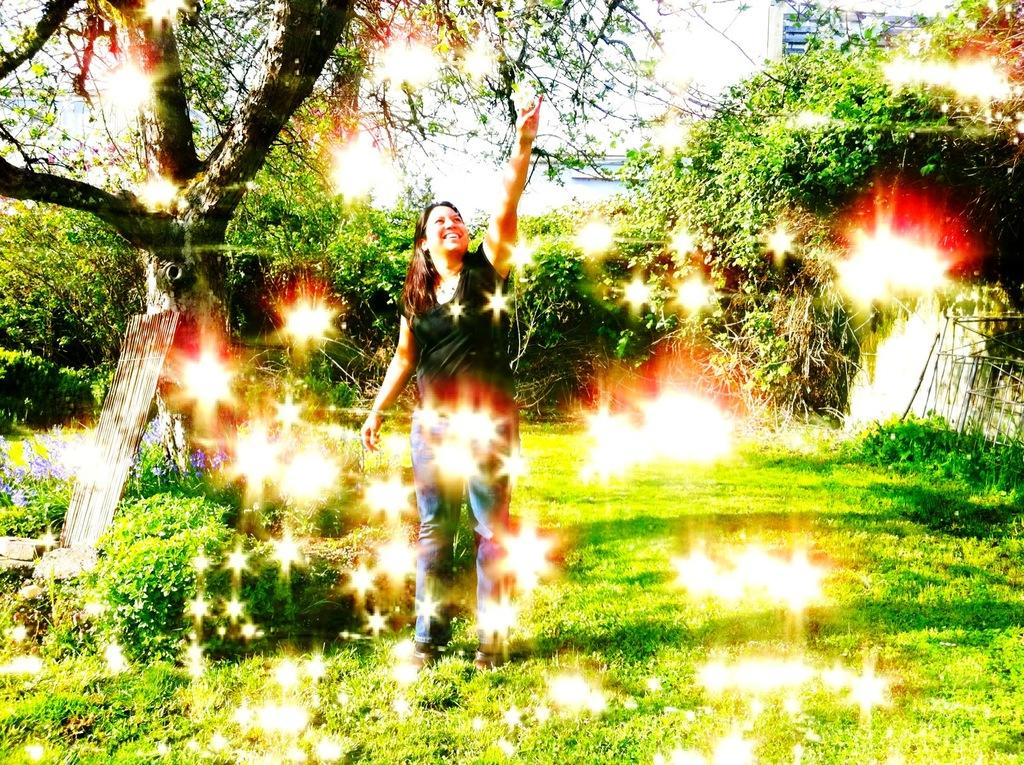What is the main subject of the image? The main subject of the image is a woman standing. What is the woman doing in the image? The woman is laughing in the image. What type of surface is the woman standing on? There is grass on the floor in the image. What can be seen in the background of the image? There are trees in the background of the image. How is the sky depicted in the image? The sky is clear in the image. What hobbies do the women at the meeting discuss in the image? There is no meeting or discussion of hobbies depicted in the image; it features a woman standing and laughing. 